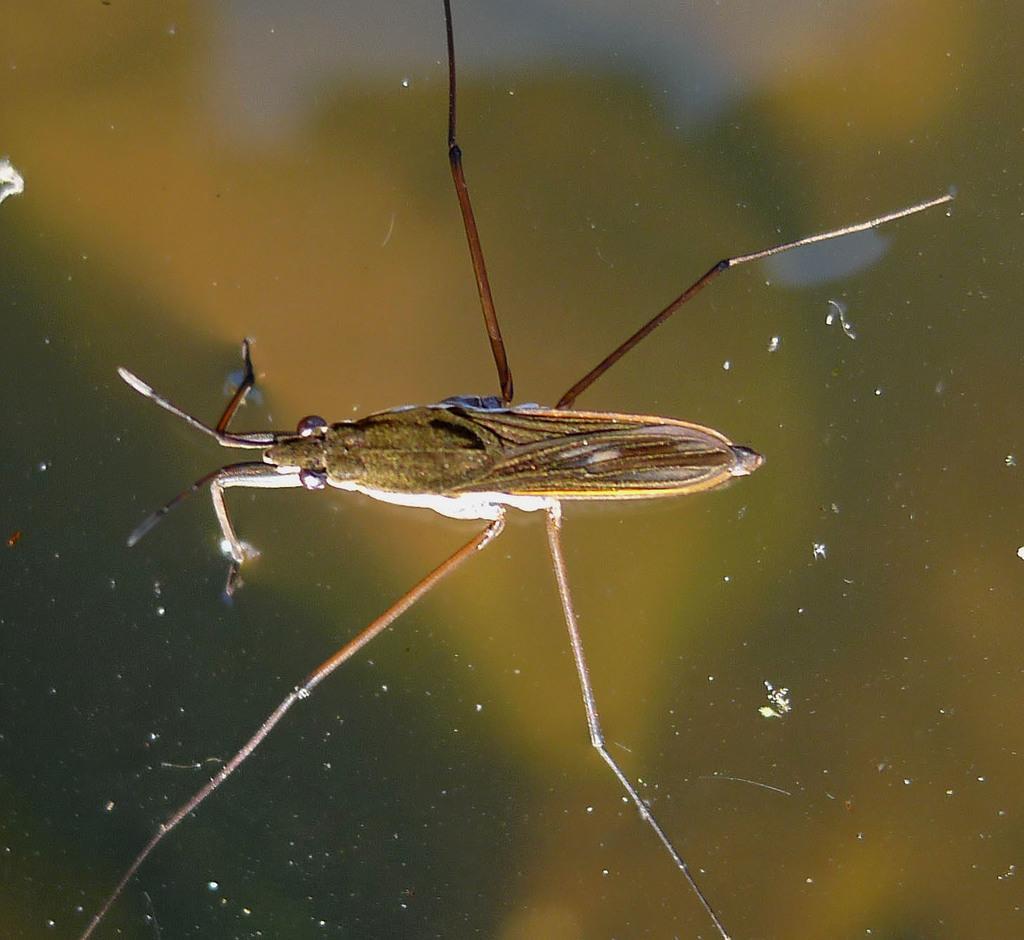Please provide a concise description of this image. In the picture we can see an insect on the water with four legs, eyes, wings and antenna. 